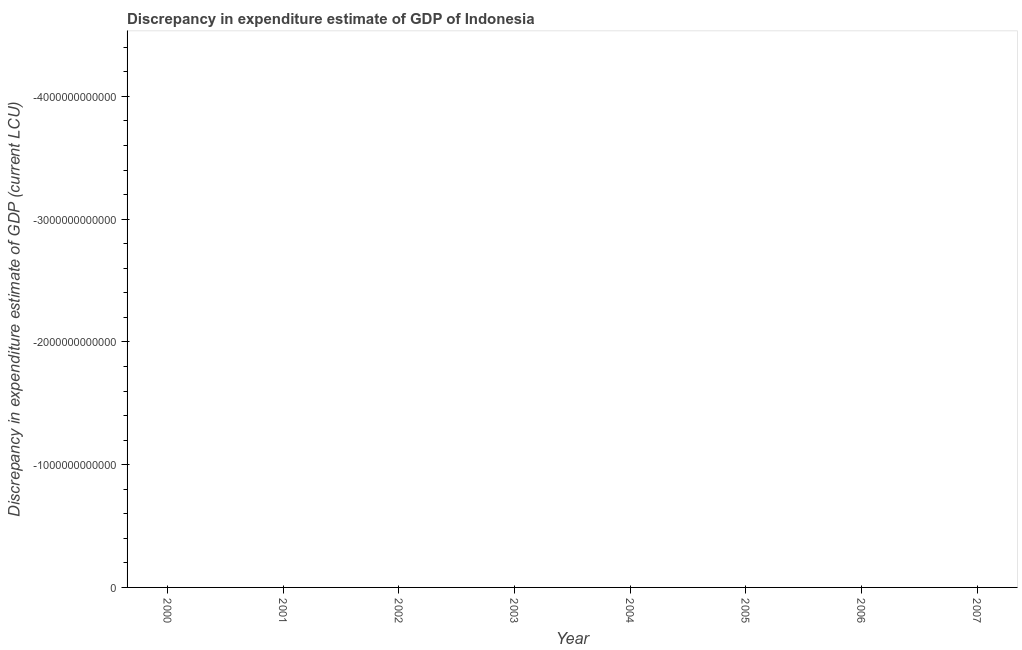What is the average discrepancy in expenditure estimate of gdp per year?
Ensure brevity in your answer.  0. What is the median discrepancy in expenditure estimate of gdp?
Your answer should be compact. 0. In how many years, is the discrepancy in expenditure estimate of gdp greater than the average discrepancy in expenditure estimate of gdp taken over all years?
Provide a succinct answer. 0. What is the difference between two consecutive major ticks on the Y-axis?
Give a very brief answer. 1.00e+12. What is the title of the graph?
Make the answer very short. Discrepancy in expenditure estimate of GDP of Indonesia. What is the label or title of the Y-axis?
Ensure brevity in your answer.  Discrepancy in expenditure estimate of GDP (current LCU). What is the Discrepancy in expenditure estimate of GDP (current LCU) of 2001?
Offer a very short reply. 0. What is the Discrepancy in expenditure estimate of GDP (current LCU) in 2002?
Provide a succinct answer. 0. What is the Discrepancy in expenditure estimate of GDP (current LCU) of 2003?
Offer a terse response. 0. What is the Discrepancy in expenditure estimate of GDP (current LCU) in 2004?
Ensure brevity in your answer.  0. What is the Discrepancy in expenditure estimate of GDP (current LCU) in 2005?
Keep it short and to the point. 0. 